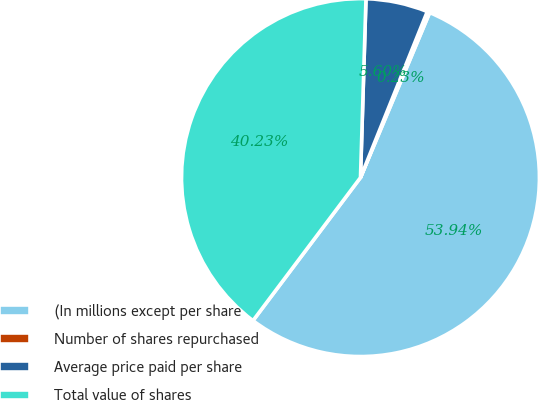<chart> <loc_0><loc_0><loc_500><loc_500><pie_chart><fcel>(In millions except per share<fcel>Number of shares repurchased<fcel>Average price paid per share<fcel>Total value of shares<nl><fcel>53.93%<fcel>0.23%<fcel>5.6%<fcel>40.23%<nl></chart> 